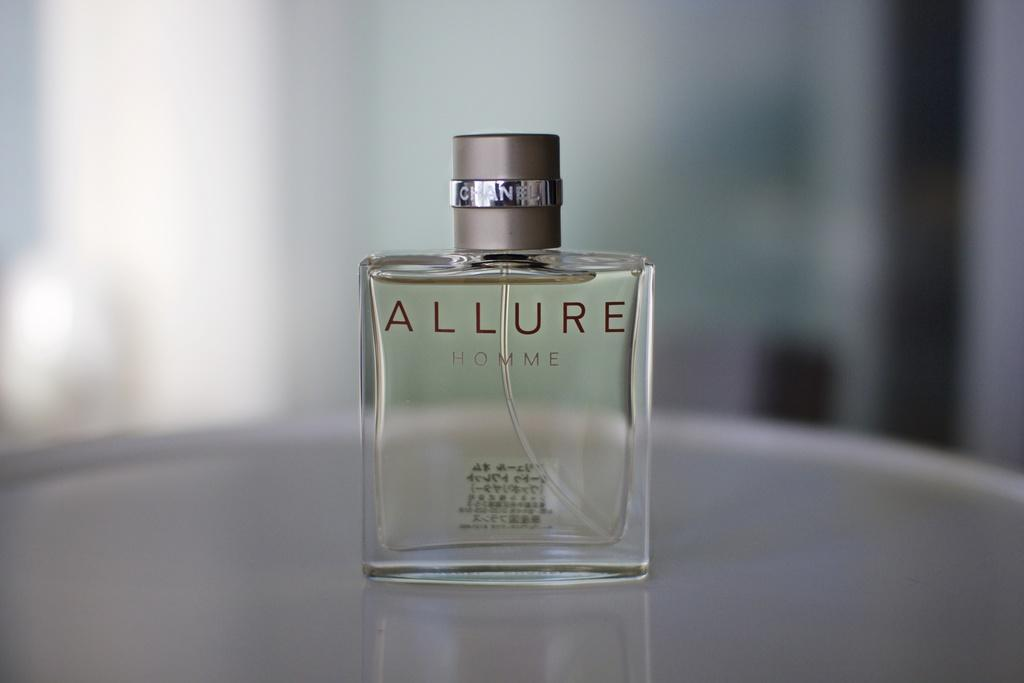Provide a one-sentence caption for the provided image. Bottle of Allure for Homme on top of a table. 